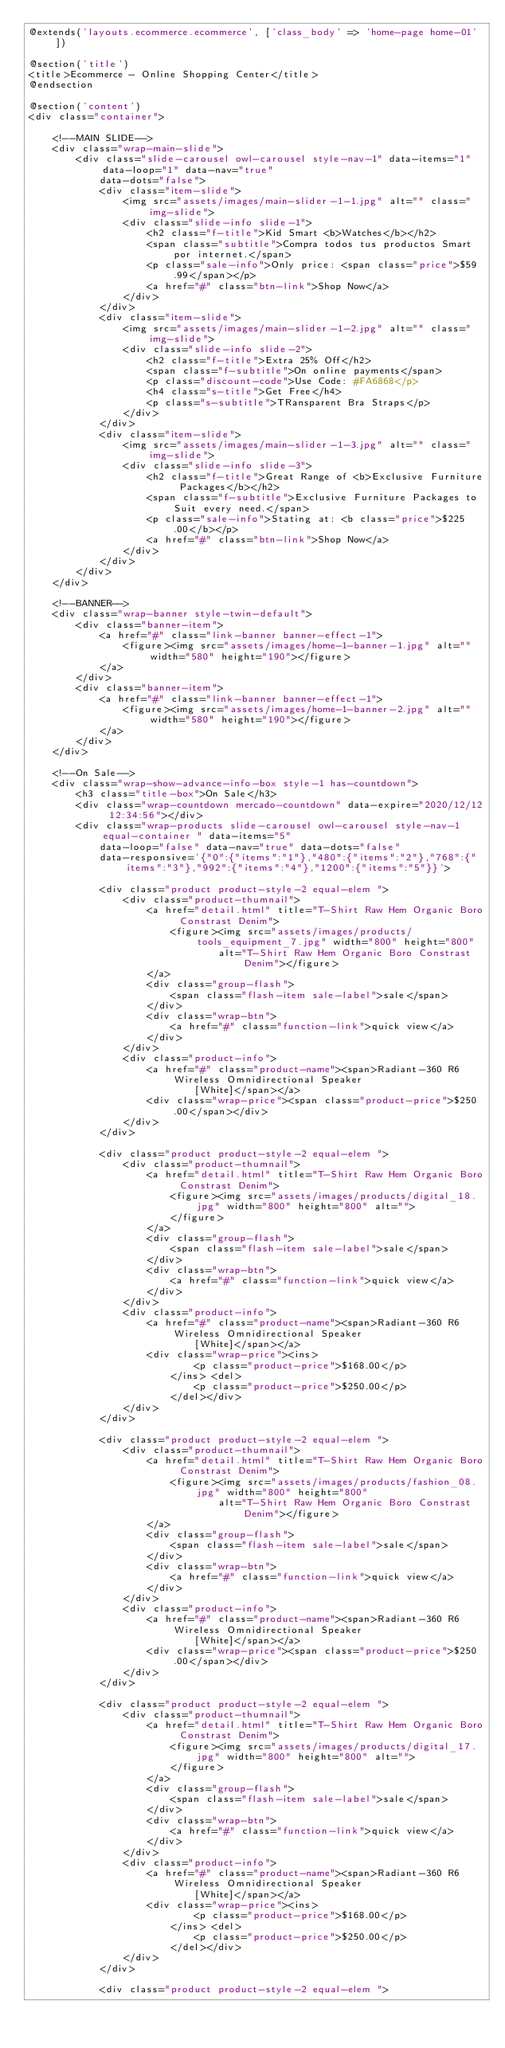<code> <loc_0><loc_0><loc_500><loc_500><_PHP_>@extends('layouts.ecommerce.ecommerce', ['class_body' => 'home-page home-01'])

@section('title')
<title>Ecommerce - Online Shopping Center</title>
@endsection

@section('content')
<div class="container">

    <!--MAIN SLIDE-->
    <div class="wrap-main-slide">
        <div class="slide-carousel owl-carousel style-nav-1" data-items="1" data-loop="1" data-nav="true"
            data-dots="false">
            <div class="item-slide">
                <img src="assets/images/main-slider-1-1.jpg" alt="" class="img-slide">
                <div class="slide-info slide-1">
                    <h2 class="f-title">Kid Smart <b>Watches</b></h2>
                    <span class="subtitle">Compra todos tus productos Smart por internet.</span>
                    <p class="sale-info">Only price: <span class="price">$59.99</span></p>
                    <a href="#" class="btn-link">Shop Now</a>
                </div>
            </div>
            <div class="item-slide">
                <img src="assets/images/main-slider-1-2.jpg" alt="" class="img-slide">
                <div class="slide-info slide-2">
                    <h2 class="f-title">Extra 25% Off</h2>
                    <span class="f-subtitle">On online payments</span>
                    <p class="discount-code">Use Code: #FA6868</p>
                    <h4 class="s-title">Get Free</h4>
                    <p class="s-subtitle">TRansparent Bra Straps</p>
                </div>
            </div>
            <div class="item-slide">
                <img src="assets/images/main-slider-1-3.jpg" alt="" class="img-slide">
                <div class="slide-info slide-3">
                    <h2 class="f-title">Great Range of <b>Exclusive Furniture Packages</b></h2>
                    <span class="f-subtitle">Exclusive Furniture Packages to Suit every need.</span>
                    <p class="sale-info">Stating at: <b class="price">$225.00</b></p>
                    <a href="#" class="btn-link">Shop Now</a>
                </div>
            </div>
        </div>
    </div>

    <!--BANNER-->
    <div class="wrap-banner style-twin-default">
        <div class="banner-item">
            <a href="#" class="link-banner banner-effect-1">
                <figure><img src="assets/images/home-1-banner-1.jpg" alt="" width="580" height="190"></figure>
            </a>
        </div>
        <div class="banner-item">
            <a href="#" class="link-banner banner-effect-1">
                <figure><img src="assets/images/home-1-banner-2.jpg" alt="" width="580" height="190"></figure>
            </a>
        </div>
    </div>

    <!--On Sale-->
    <div class="wrap-show-advance-info-box style-1 has-countdown">
        <h3 class="title-box">On Sale</h3>
        <div class="wrap-countdown mercado-countdown" data-expire="2020/12/12 12:34:56"></div>
        <div class="wrap-products slide-carousel owl-carousel style-nav-1 equal-container " data-items="5"
            data-loop="false" data-nav="true" data-dots="false"
            data-responsive='{"0":{"items":"1"},"480":{"items":"2"},"768":{"items":"3"},"992":{"items":"4"},"1200":{"items":"5"}}'>

            <div class="product product-style-2 equal-elem ">
                <div class="product-thumnail">
                    <a href="detail.html" title="T-Shirt Raw Hem Organic Boro Constrast Denim">
                        <figure><img src="assets/images/products/tools_equipment_7.jpg" width="800" height="800"
                                alt="T-Shirt Raw Hem Organic Boro Constrast Denim"></figure>
                    </a>
                    <div class="group-flash">
                        <span class="flash-item sale-label">sale</span>
                    </div>
                    <div class="wrap-btn">
                        <a href="#" class="function-link">quick view</a>
                    </div>
                </div>
                <div class="product-info">
                    <a href="#" class="product-name"><span>Radiant-360 R6 Wireless Omnidirectional Speaker
                            [White]</span></a>
                    <div class="wrap-price"><span class="product-price">$250.00</span></div>
                </div>
            </div>

            <div class="product product-style-2 equal-elem ">
                <div class="product-thumnail">
                    <a href="detail.html" title="T-Shirt Raw Hem Organic Boro Constrast Denim">
                        <figure><img src="assets/images/products/digital_18.jpg" width="800" height="800" alt="">
                        </figure>
                    </a>
                    <div class="group-flash">
                        <span class="flash-item sale-label">sale</span>
                    </div>
                    <div class="wrap-btn">
                        <a href="#" class="function-link">quick view</a>
                    </div>
                </div>
                <div class="product-info">
                    <a href="#" class="product-name"><span>Radiant-360 R6 Wireless Omnidirectional Speaker
                            [White]</span></a>
                    <div class="wrap-price"><ins>
                            <p class="product-price">$168.00</p>
                        </ins> <del>
                            <p class="product-price">$250.00</p>
                        </del></div>
                </div>
            </div>

            <div class="product product-style-2 equal-elem ">
                <div class="product-thumnail">
                    <a href="detail.html" title="T-Shirt Raw Hem Organic Boro Constrast Denim">
                        <figure><img src="assets/images/products/fashion_08.jpg" width="800" height="800"
                                alt="T-Shirt Raw Hem Organic Boro Constrast Denim"></figure>
                    </a>
                    <div class="group-flash">
                        <span class="flash-item sale-label">sale</span>
                    </div>
                    <div class="wrap-btn">
                        <a href="#" class="function-link">quick view</a>
                    </div>
                </div>
                <div class="product-info">
                    <a href="#" class="product-name"><span>Radiant-360 R6 Wireless Omnidirectional Speaker
                            [White]</span></a>
                    <div class="wrap-price"><span class="product-price">$250.00</span></div>
                </div>
            </div>

            <div class="product product-style-2 equal-elem ">
                <div class="product-thumnail">
                    <a href="detail.html" title="T-Shirt Raw Hem Organic Boro Constrast Denim">
                        <figure><img src="assets/images/products/digital_17.jpg" width="800" height="800" alt="">
                        </figure>
                    </a>
                    <div class="group-flash">
                        <span class="flash-item sale-label">sale</span>
                    </div>
                    <div class="wrap-btn">
                        <a href="#" class="function-link">quick view</a>
                    </div>
                </div>
                <div class="product-info">
                    <a href="#" class="product-name"><span>Radiant-360 R6 Wireless Omnidirectional Speaker
                            [White]</span></a>
                    <div class="wrap-price"><ins>
                            <p class="product-price">$168.00</p>
                        </ins> <del>
                            <p class="product-price">$250.00</p>
                        </del></div>
                </div>
            </div>

            <div class="product product-style-2 equal-elem "></code> 